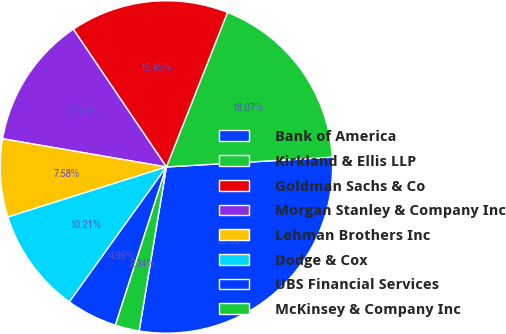<chart> <loc_0><loc_0><loc_500><loc_500><pie_chart><fcel>Bank of America<fcel>Kirkland & Ellis LLP<fcel>Goldman Sachs & Co<fcel>Morgan Stanley & Company Inc<fcel>Lehman Brothers Inc<fcel>Dodge & Cox<fcel>UBS Financial Services<fcel>McKinsey & Company Inc<nl><fcel>28.56%<fcel>18.07%<fcel>15.45%<fcel>12.83%<fcel>7.58%<fcel>10.21%<fcel>4.96%<fcel>2.34%<nl></chart> 